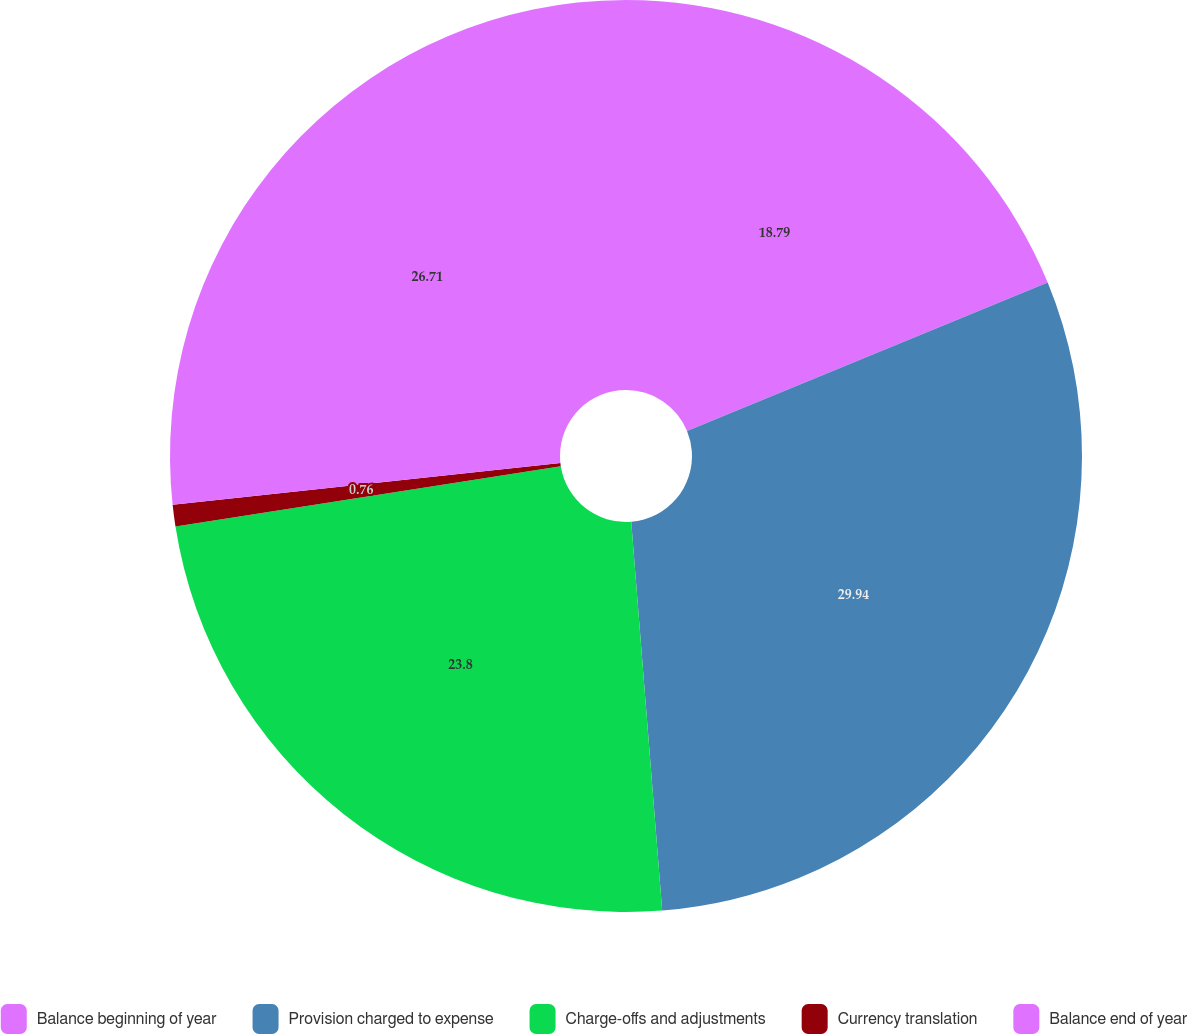<chart> <loc_0><loc_0><loc_500><loc_500><pie_chart><fcel>Balance beginning of year<fcel>Provision charged to expense<fcel>Charge-offs and adjustments<fcel>Currency translation<fcel>Balance end of year<nl><fcel>18.79%<fcel>29.95%<fcel>23.8%<fcel>0.76%<fcel>26.71%<nl></chart> 